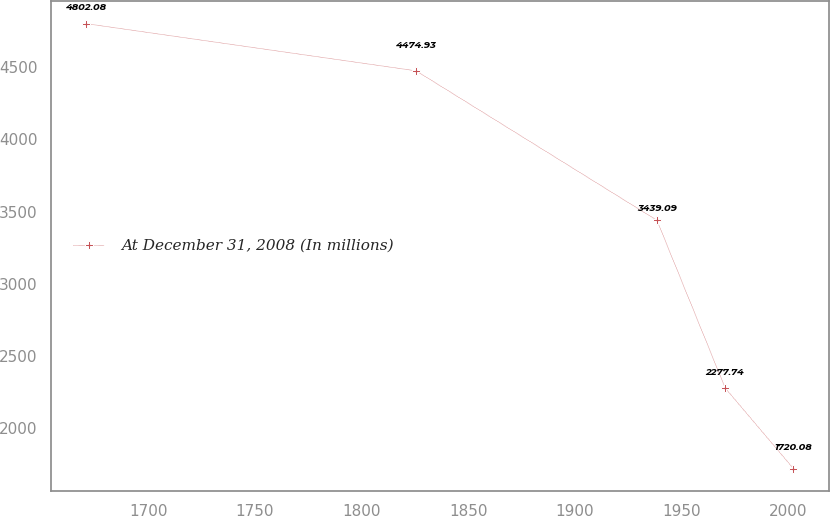<chart> <loc_0><loc_0><loc_500><loc_500><line_chart><ecel><fcel>At December 31, 2008 (In millions)<nl><fcel>1670.7<fcel>4802.08<nl><fcel>1825.61<fcel>4474.93<nl><fcel>1938.59<fcel>3439.09<nl><fcel>1970.58<fcel>2277.74<nl><fcel>2002.57<fcel>1720.08<nl></chart> 